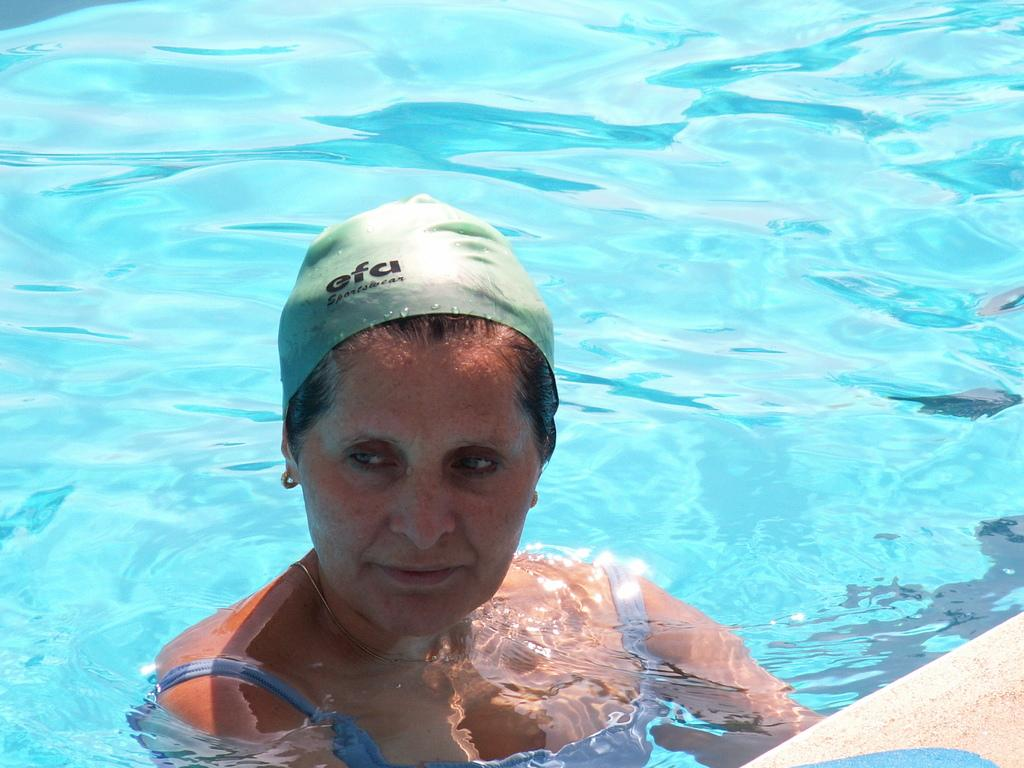What is the main subject of the image? The main subject of the image is a woman in the water. Can you describe the woman's attire? The woman is wearing a different costume. What else can be seen in the image? There is a platform at the bottom right side of the image. What type of ice can be seen growing on the woman's costume in the image? There is no ice present in the image, and the woman's costume is not growing. 